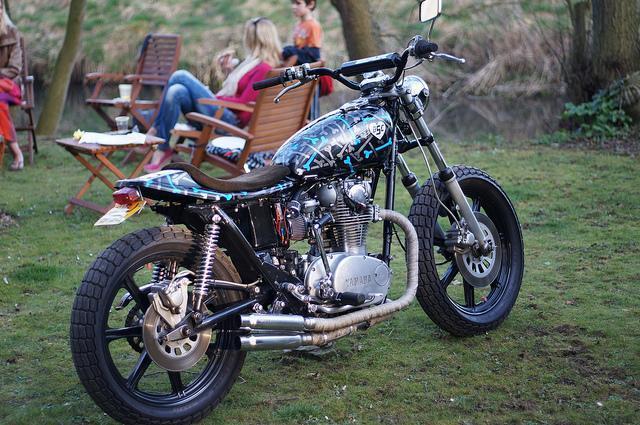How many people are in the photo?
Give a very brief answer. 2. How many chairs can be seen?
Give a very brief answer. 2. 